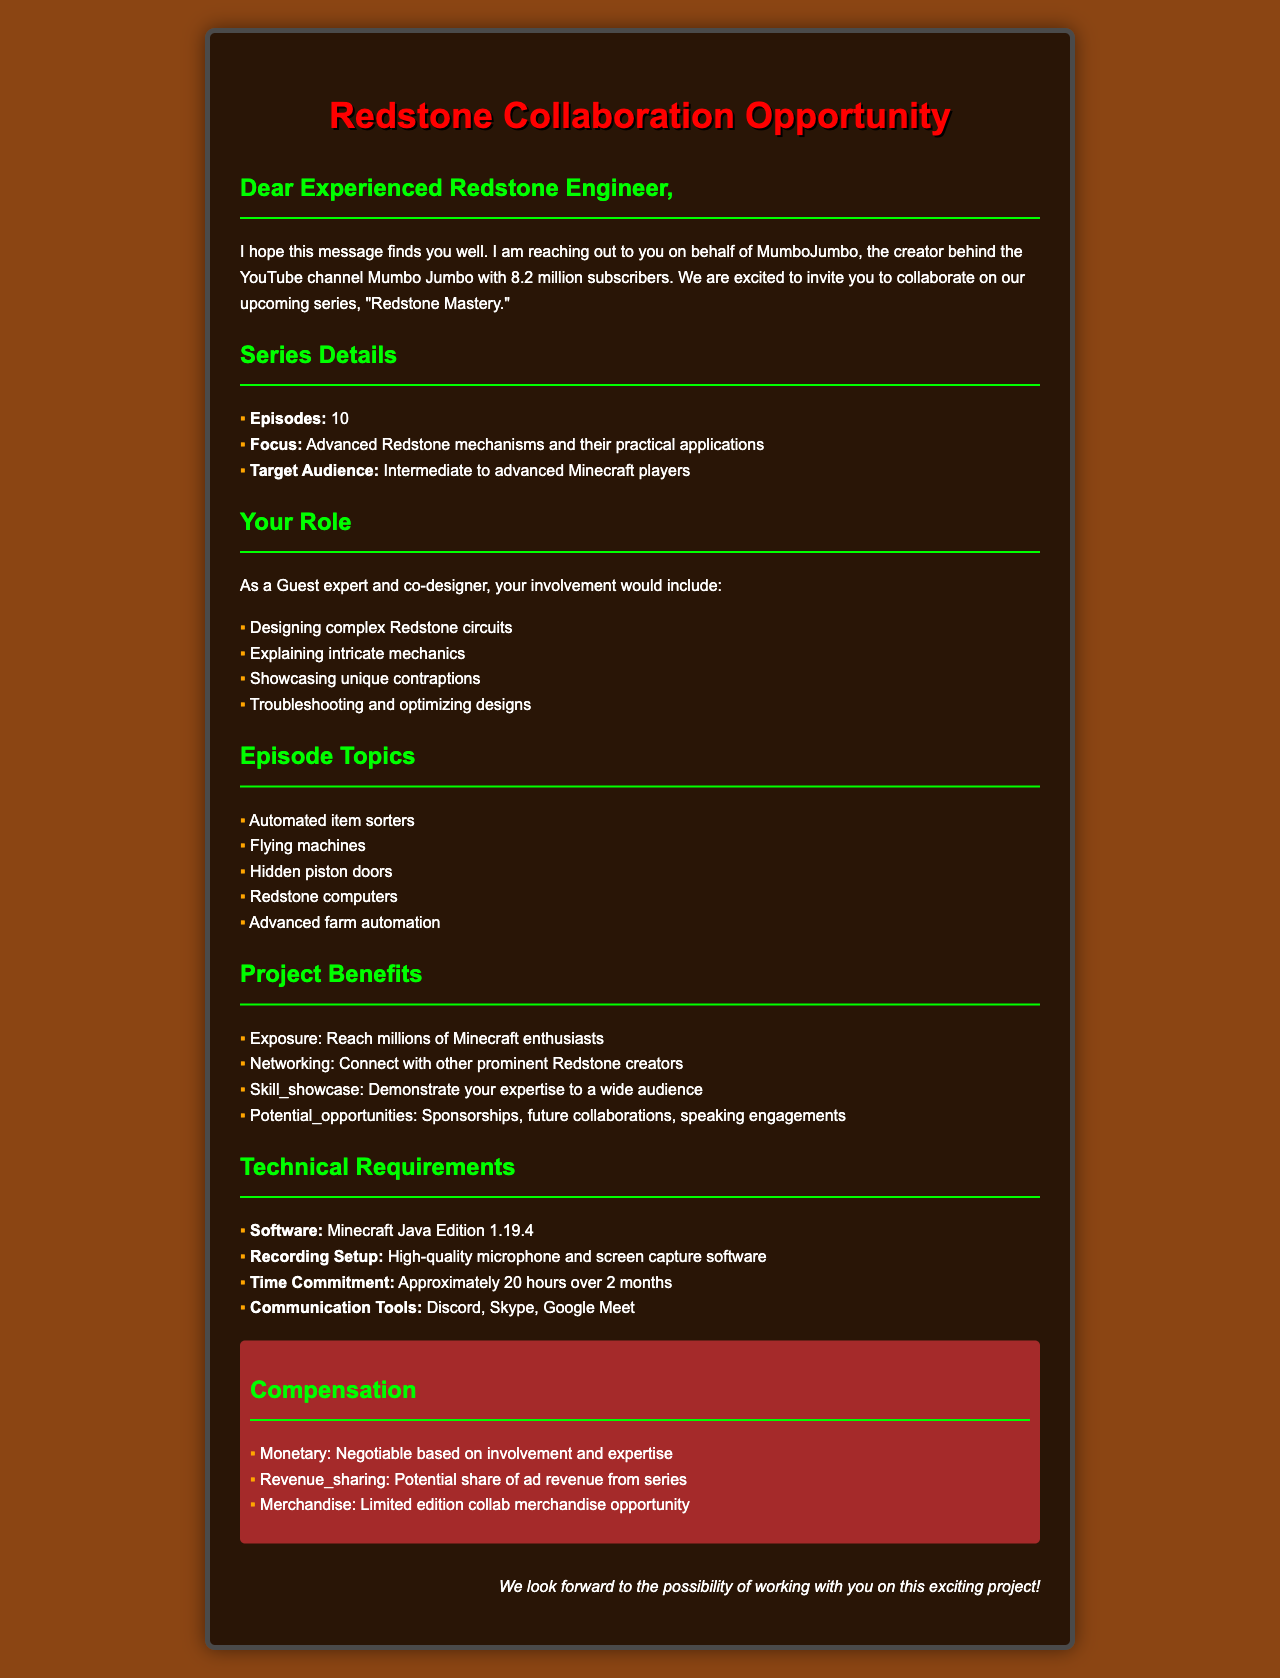What is the name of the YouTuber? The name of the YouTuber is stated in the document, which is MumboJumbo.
Answer: MumboJumbo How many episodes are in the series? The document specifies that the series titled "Redstone Mastery" consists of 10 episodes.
Answer: 10 What is the main focus of the collaboration? The document describes the series focus as Advanced Redstone mechanisms and their practical applications.
Answer: Advanced Redstone mechanisms and their practical applications What are the communication tools mentioned? The document lists the communication tools required for the collaboration, which are Discord, Skype, and Google Meet.
Answer: Discord, Skype, Google Meet What is the time commitment for the project? The document indicates that the total time commitment for the collaboration is approximately 20 hours over 2 months.
Answer: Approximately 20 hours over 2 months What are some episode topics for the series? The document provides a list of episode topics, including Automated item sorters and Flying machines.
Answer: Automated item sorters, Flying machines What role will the experienced Redstone engineer have? The document details that the engineer's role will be Guest expert and co-designer.
Answer: Guest expert and co-designer What is the compensation type mentioned for the collaboration? The compensation details mentioned in the document include monetary compensation and revenue sharing.
Answer: Negotiable based on involvement and expertise What is a potential challenge mentioned for the series? The document highlights a potential challenge of explaining complex concepts in an understandable manner.
Answer: Explaining complex concepts in an understandable manner 